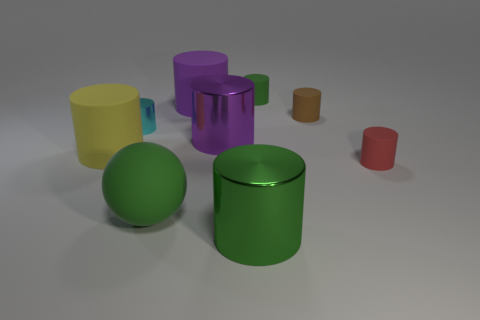What materials do the objects in the image seem to be made of? The objects in the image appear to be made of different materials with varying finishes, such as matte, reflective, and translucent surfaces, possibly representing plastics or metals in the context of 3D rendering. 